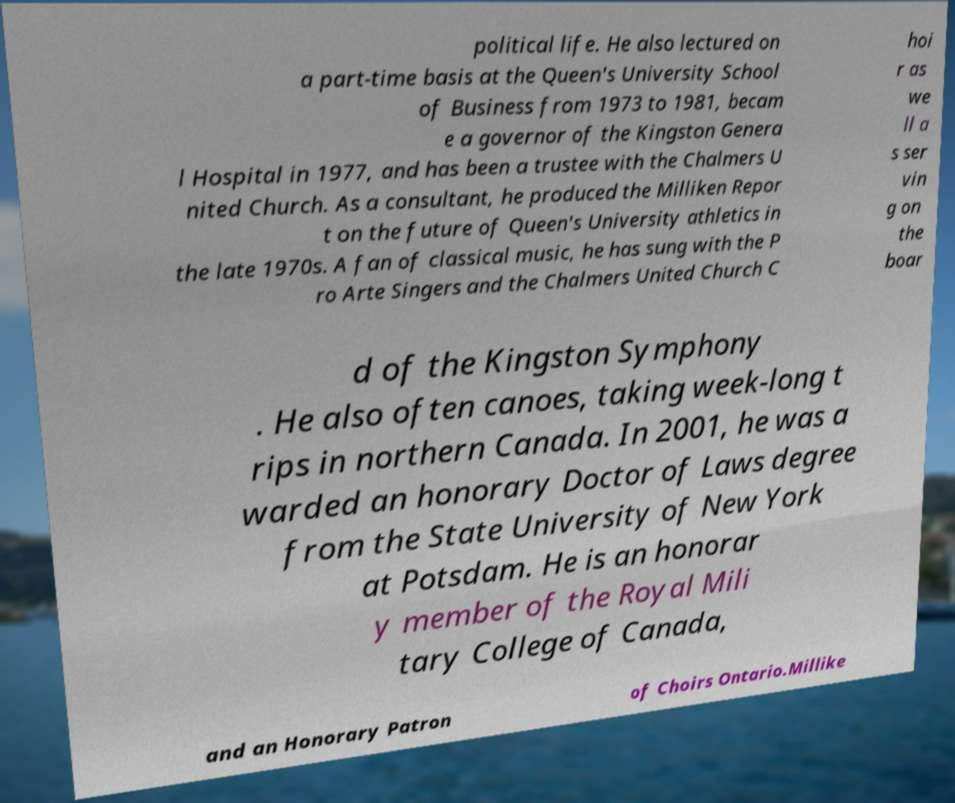I need the written content from this picture converted into text. Can you do that? political life. He also lectured on a part-time basis at the Queen's University School of Business from 1973 to 1981, becam e a governor of the Kingston Genera l Hospital in 1977, and has been a trustee with the Chalmers U nited Church. As a consultant, he produced the Milliken Repor t on the future of Queen's University athletics in the late 1970s. A fan of classical music, he has sung with the P ro Arte Singers and the Chalmers United Church C hoi r as we ll a s ser vin g on the boar d of the Kingston Symphony . He also often canoes, taking week-long t rips in northern Canada. In 2001, he was a warded an honorary Doctor of Laws degree from the State University of New York at Potsdam. He is an honorar y member of the Royal Mili tary College of Canada, and an Honorary Patron of Choirs Ontario.Millike 